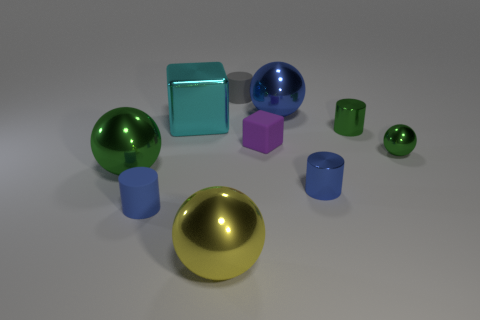Subtract 1 balls. How many balls are left? 3 Subtract all brown cylinders. Subtract all green blocks. How many cylinders are left? 4 Subtract all spheres. How many objects are left? 6 Add 9 purple rubber balls. How many purple rubber balls exist? 9 Subtract 0 red spheres. How many objects are left? 10 Subtract all shiny cubes. Subtract all matte cylinders. How many objects are left? 7 Add 6 small green shiny things. How many small green shiny things are left? 8 